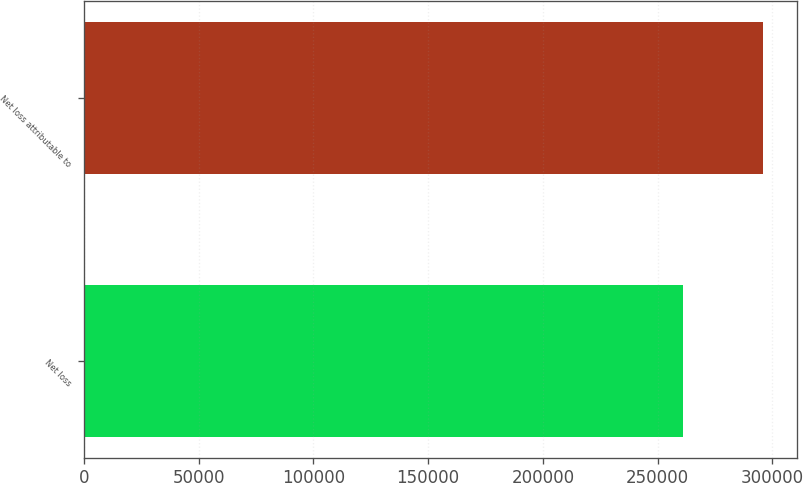<chart> <loc_0><loc_0><loc_500><loc_500><bar_chart><fcel>Net loss<fcel>Net loss attributable to<nl><fcel>260882<fcel>296097<nl></chart> 